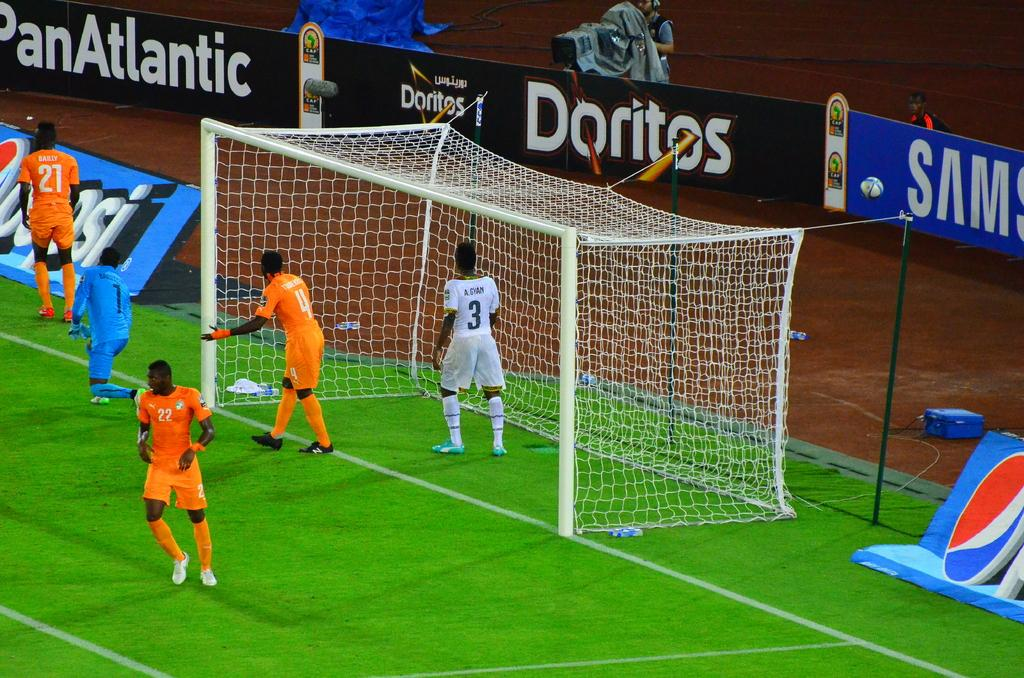<image>
Share a concise interpretation of the image provided. Soccer players are on a field with an advertisement for Doritos behind them. 